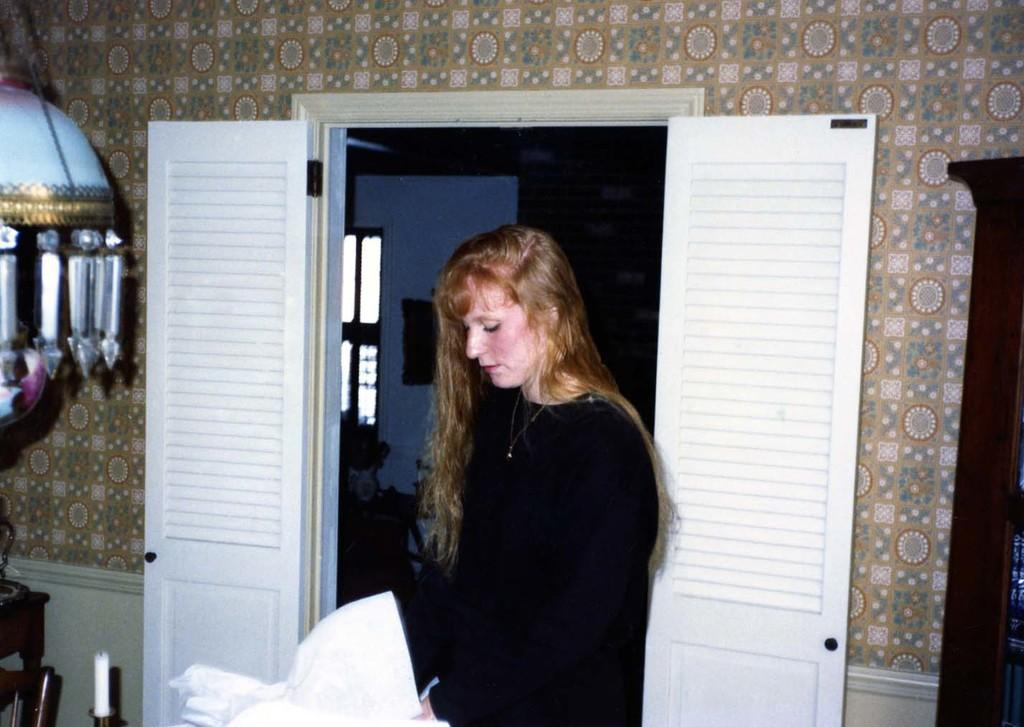What is the person in the image wearing? The person in the image is wearing a black dress. What can be seen in the image besides the person? There is a candle, doors, a window, and a wall visible in the image. Can you describe the candle in the image? The candle is an object that can provide light and is present in the image. What architectural features are present in the image? Doors, a window, and a wall are present in the image. How many children are sitting on the cushion in the image? There is no cushion or children present in the image. What season is depicted in the image? The provided facts do not mention any season or time of year, so it cannot be determined from the image. 